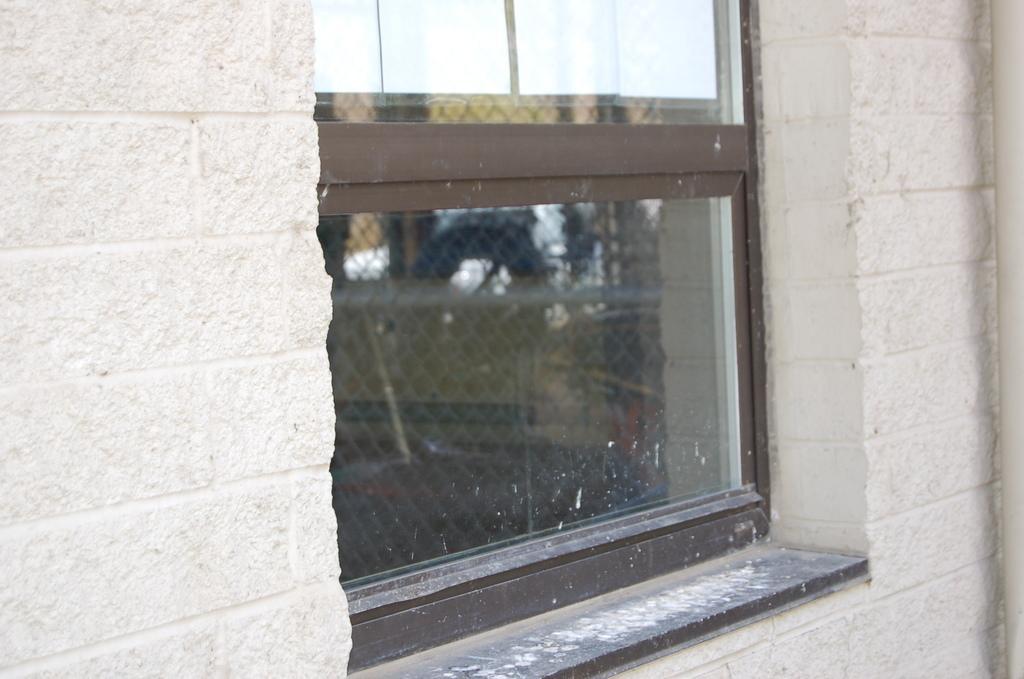In one or two sentences, can you explain what this image depicts? In this picture I can see the glass windows in the middle. There is the wall. 